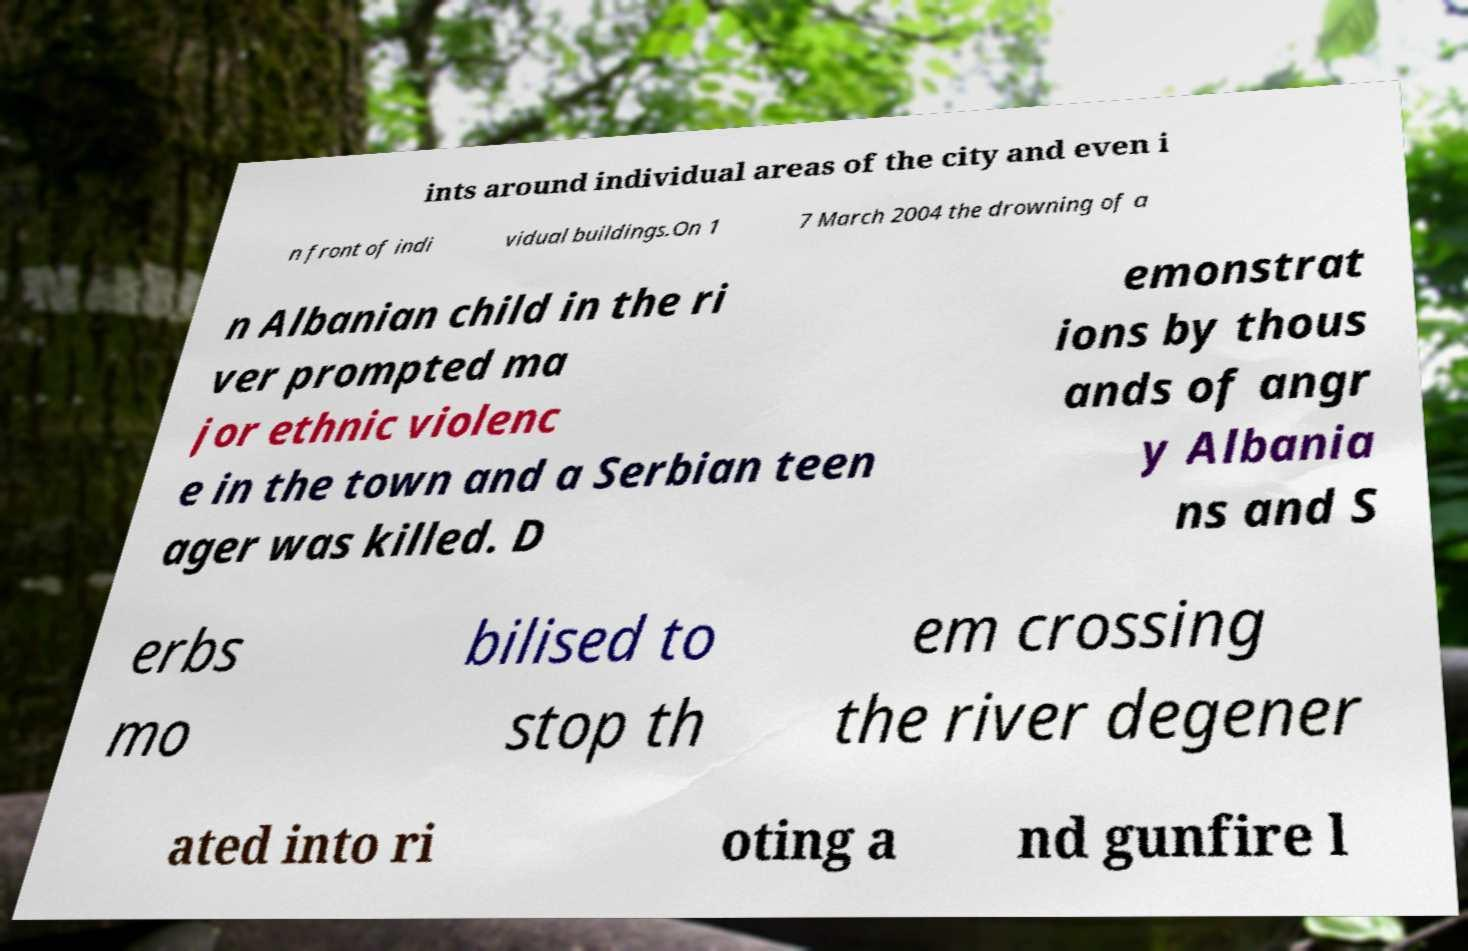Please read and relay the text visible in this image. What does it say? ints around individual areas of the city and even i n front of indi vidual buildings.On 1 7 March 2004 the drowning of a n Albanian child in the ri ver prompted ma jor ethnic violenc e in the town and a Serbian teen ager was killed. D emonstrat ions by thous ands of angr y Albania ns and S erbs mo bilised to stop th em crossing the river degener ated into ri oting a nd gunfire l 